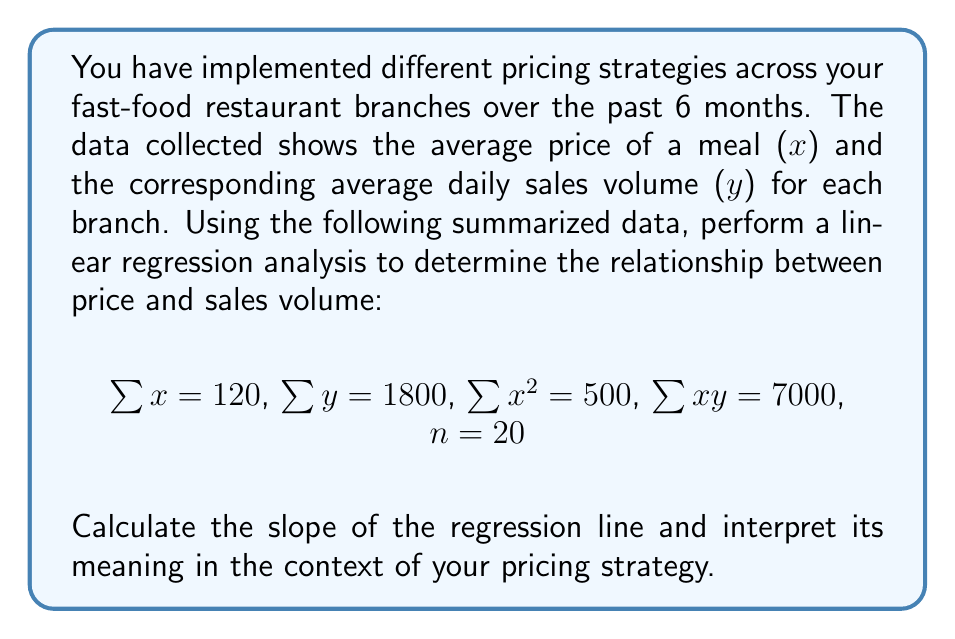Help me with this question. To perform linear regression analysis and find the slope, we'll follow these steps:

1) The linear regression equation is $y = mx + b$, where $m$ is the slope and $b$ is the y-intercept.

2) The formula for the slope $m$ is:

   $$m = \frac{n\sum xy - \sum x \sum y}{n\sum x^2 - (\sum x)^2}$$

3) Let's substitute the given values:
   $n = 20$
   $\sum x = 120$
   $\sum y = 1800$
   $\sum x^2 = 500$
   $\sum xy = 7000$

4) Calculate the slope:

   $$m = \frac{20(7000) - (120)(1800)}{20(500) - (120)^2}$$

   $$m = \frac{140000 - 216000}{10000 - 14400}$$

   $$m = \frac{-76000}{-4400} = 17.27$$

5) Interpret the result:
   The slope is approximately 17.27. This means that for every $1 increase in the price of a meal, the average daily sales volume decreases by about 17.27 units.

This negative slope indicates an inverse relationship between price and sales volume, which is typically expected in most markets (as price increases, demand usually decreases).
Answer: 17.27 (units sold per dollar price increase) 